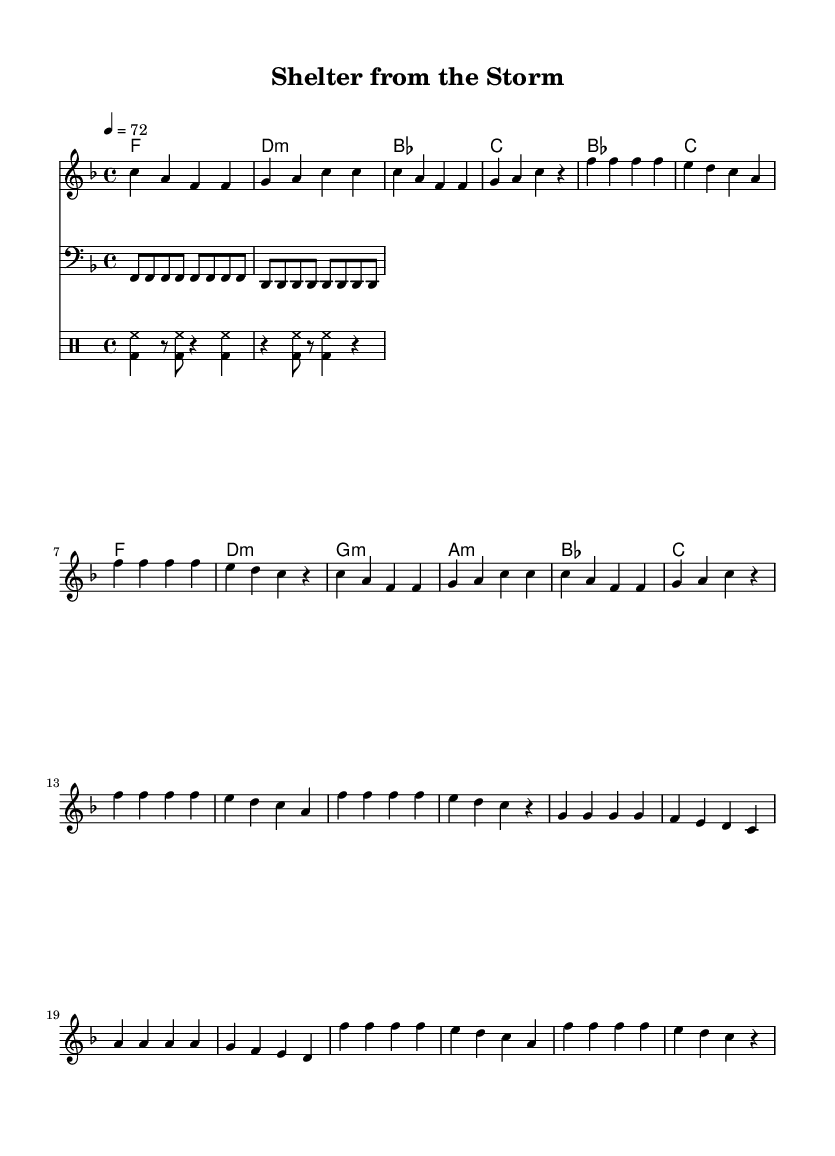What is the key signature of this music? The key signature is indicated at the beginning of the staff. It shows one flat (B) after the clef, which confirms that the music is in F major.
Answer: F major What is the time signature of the piece? The time signature is represented as a fraction at the beginning of the staff. It shows 4 over 4, meaning there are four beats in a measure and each quarter note gets one beat.
Answer: 4/4 What is the tempo marking for this piece? The tempo marking appears at the beginning within the global settings and indicates the speed of the piece. It shows that the piece should be played at 72 beats per minute.
Answer: 72 How many measures are in the chorus? To find the number of measures in the chorus, we can count the number of bars in the chorus section shown in the melody. There are 4 measures in the chorus part of the song.
Answer: 4 What are the main themes represented in the lyrics? The lyrics convey themes of love and protection as the singer promises to keep their loved ones safe from life's challenges. The comforting imagery creates a sense of security.
Answer: Love and protection Which chord appears first in the harmony section? The harmonies are displayed in a sequence at the beginning. The first chord, written in the chord names, is F major, signifying the tonal center of the piece.
Answer: F What is the role of the bass part in this piece? The bass part provides the harmonic foundation and drives the rhythm. By playing steady quarter notes, it supports the chords and maintains the groove necessary for Rhythm and Blues.
Answer: Harmonic foundation 